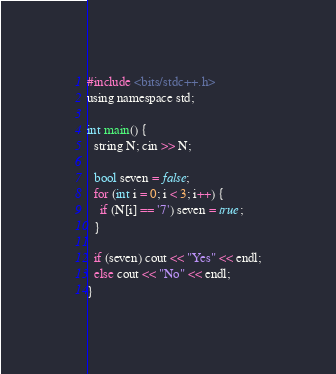Convert code to text. <code><loc_0><loc_0><loc_500><loc_500><_C_>#include <bits/stdc++.h>
using namespace std;

int main() {
  string N; cin >> N;
  
  bool seven = false;
  for (int i = 0; i < 3; i++) {
    if (N[i] == '7') seven = true;
  }
  
  if (seven) cout << "Yes" << endl;
  else cout << "No" << endl;
}</code> 